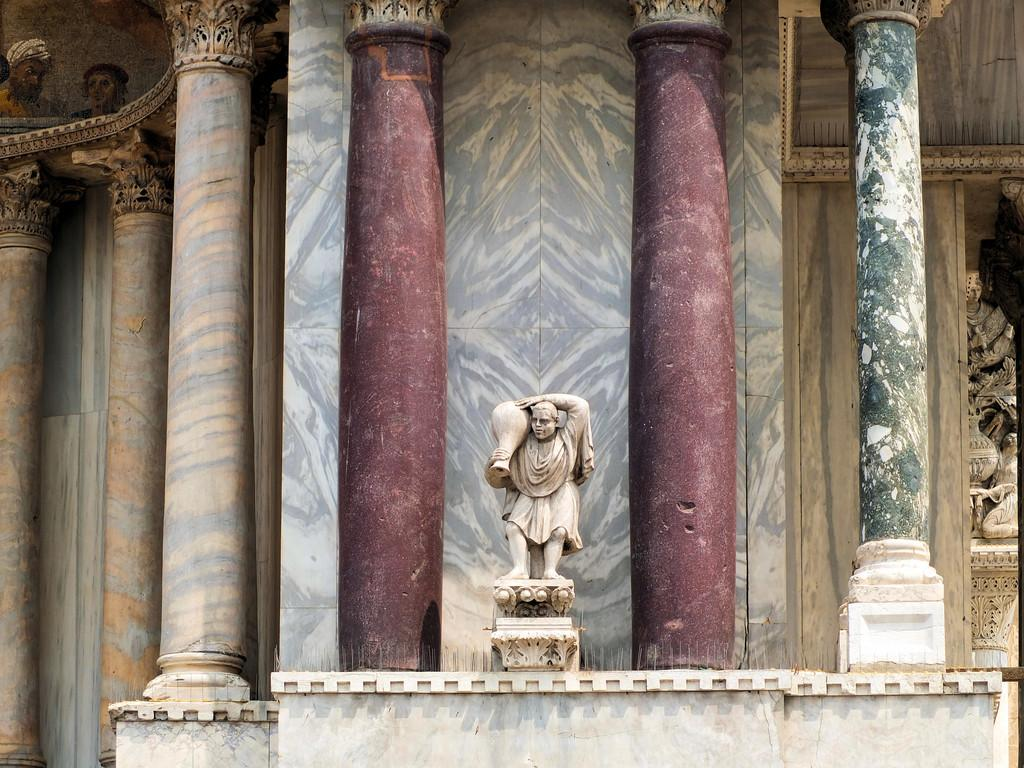What is the main subject in the middle of the image? There is a statue of a person in the image. What is the statue surrounded by? The statue is surrounded by pillars on both sides. What can be seen in the background of the image? There is a wall in the background of the image. What country does the parent of the statue come from? The image does not provide information about the statue's parent or the statue's origin, so it cannot be determined from the image. 